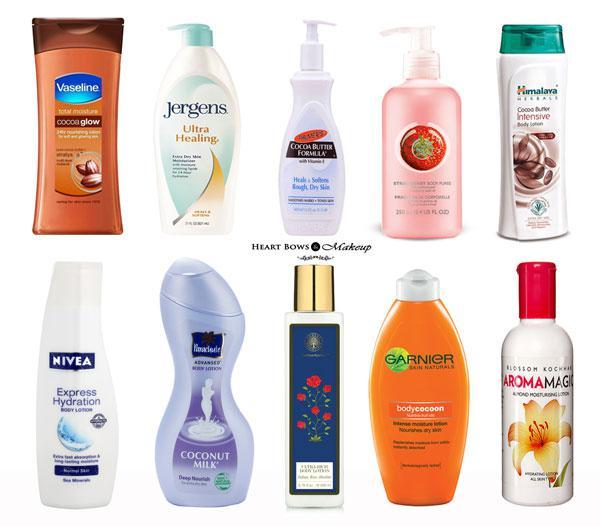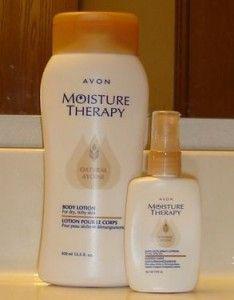The first image is the image on the left, the second image is the image on the right. Given the left and right images, does the statement "There are hands applying products in the images." hold true? Answer yes or no. No. The first image is the image on the left, the second image is the image on the right. Assess this claim about the two images: "In at least one of the image, lotion is being applied to a hand.". Correct or not? Answer yes or no. No. 